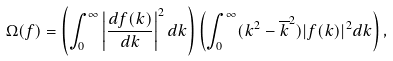Convert formula to latex. <formula><loc_0><loc_0><loc_500><loc_500>\Omega ( f ) = \left ( \int _ { 0 } ^ { \infty } \left | \frac { d f ( k ) } { d k } \right | ^ { 2 } d k \right ) \left ( \int _ { 0 } ^ { \infty } ( k ^ { 2 } - \overline { k } ^ { 2 } ) | f ( k ) | ^ { 2 } d k \right ) ,</formula> 